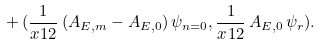Convert formula to latex. <formula><loc_0><loc_0><loc_500><loc_500>+ \, ( \frac { 1 } { x ^ { } { 1 } 2 } \, ( A _ { E , m } - A _ { E , 0 } ) \, \psi _ { n = 0 } , \frac { 1 } { x ^ { } { 1 } 2 } \, A _ { E , 0 } \, \psi _ { r } ) .</formula> 